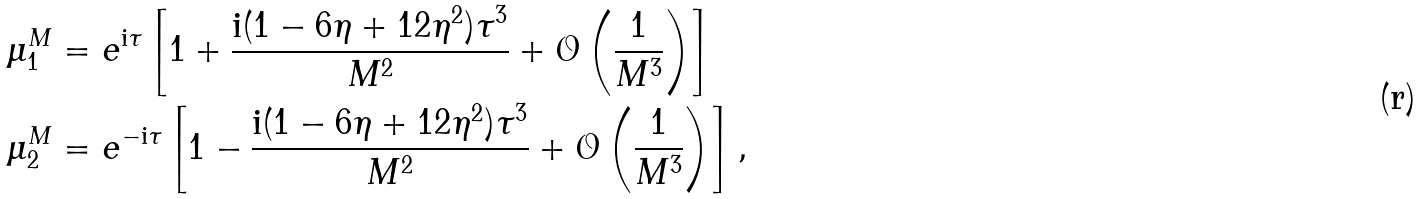<formula> <loc_0><loc_0><loc_500><loc_500>\mu _ { 1 } ^ { M } & = e ^ { \mathrm i \tau } \left [ 1 + \frac { \mathrm i ( 1 - 6 \eta + 1 2 \eta ^ { 2 } ) \tau ^ { 3 } } { M ^ { 2 } } + \mathcal { O } \left ( \frac { 1 } { M ^ { 3 } } \right ) \right ] \\ \mu _ { 2 } ^ { M } & = e ^ { - \mathrm i \tau } \left [ 1 - \frac { \mathrm i ( 1 - 6 \eta + 1 2 \eta ^ { 2 } ) \tau ^ { 3 } } { M ^ { 2 } } + \mathcal { O } \left ( \frac { 1 } { M ^ { 3 } } \right ) \right ] ,</formula> 